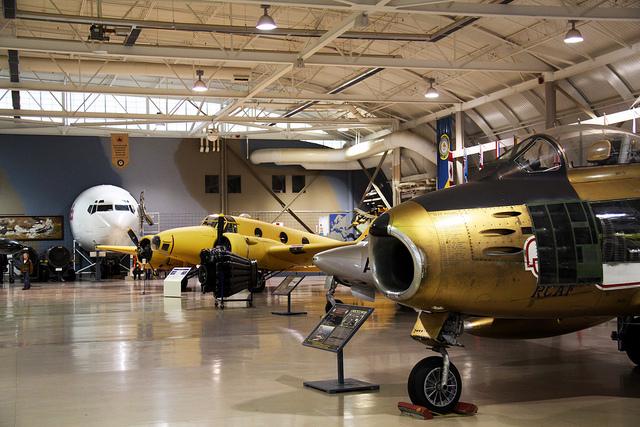Is this a museum?
Short answer required. Yes. What color is back wall?
Concise answer only. Blue, white, and tan. What kind of museum is this?
Quick response, please. Airplane. 